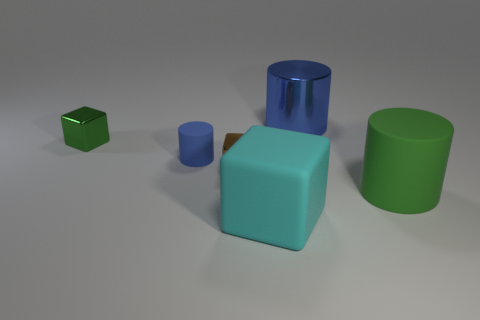How many metal blocks have the same color as the large shiny cylinder? In the image, there are no other metal blocks that share the same color as the large shiny blue cylinder. The objects present display a variety of colors, but none match the blue cylinder in hue and material properties. 